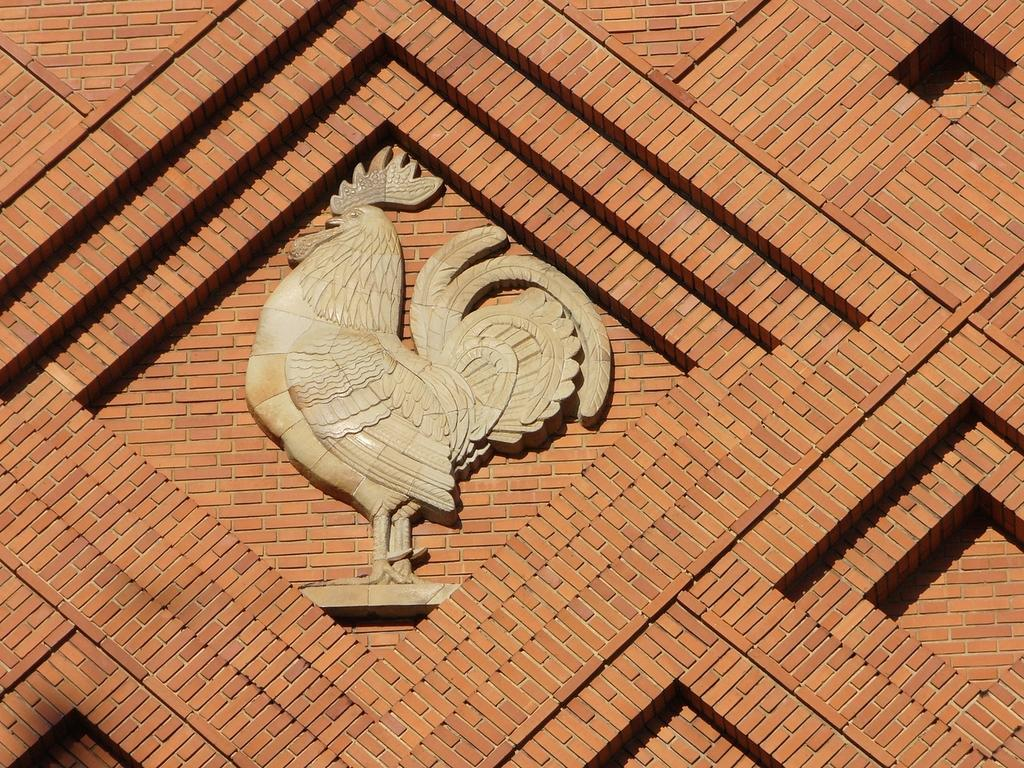What is the main subject of the picture? The main subject of the picture is a sculpture of a rooster. What color is the sculpture? The sculpture is in cream color. What can be seen in the background of the image? There is a wall in the background of the image. Can you tell me how many seeds are present in the sculpture? There are no seeds present in the sculpture; it is a sculpture of a rooster. What example of a different animal can be seen in the image? There is no other animal depicted in the image; it features a sculpture of a rooster. 